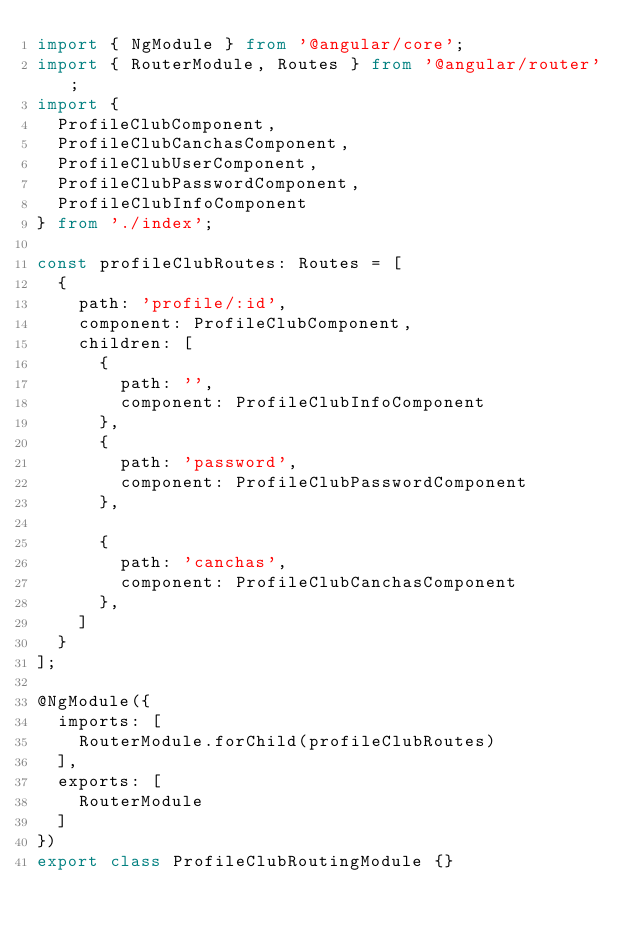Convert code to text. <code><loc_0><loc_0><loc_500><loc_500><_TypeScript_>import { NgModule } from '@angular/core';
import { RouterModule, Routes } from '@angular/router';
import {
  ProfileClubComponent,
  ProfileClubCanchasComponent,
  ProfileClubUserComponent,
  ProfileClubPasswordComponent,
  ProfileClubInfoComponent
} from './index';

const profileClubRoutes: Routes = [
  {
    path: 'profile/:id',
    component: ProfileClubComponent,
    children: [
      {
        path: '',
        component: ProfileClubInfoComponent
      },
      {
        path: 'password',
        component: ProfileClubPasswordComponent
      },

      {
        path: 'canchas',
        component: ProfileClubCanchasComponent
      },
    ]
  }
];

@NgModule({
  imports: [
    RouterModule.forChild(profileClubRoutes)
  ],
  exports: [
    RouterModule
  ]
})
export class ProfileClubRoutingModule {}
</code> 